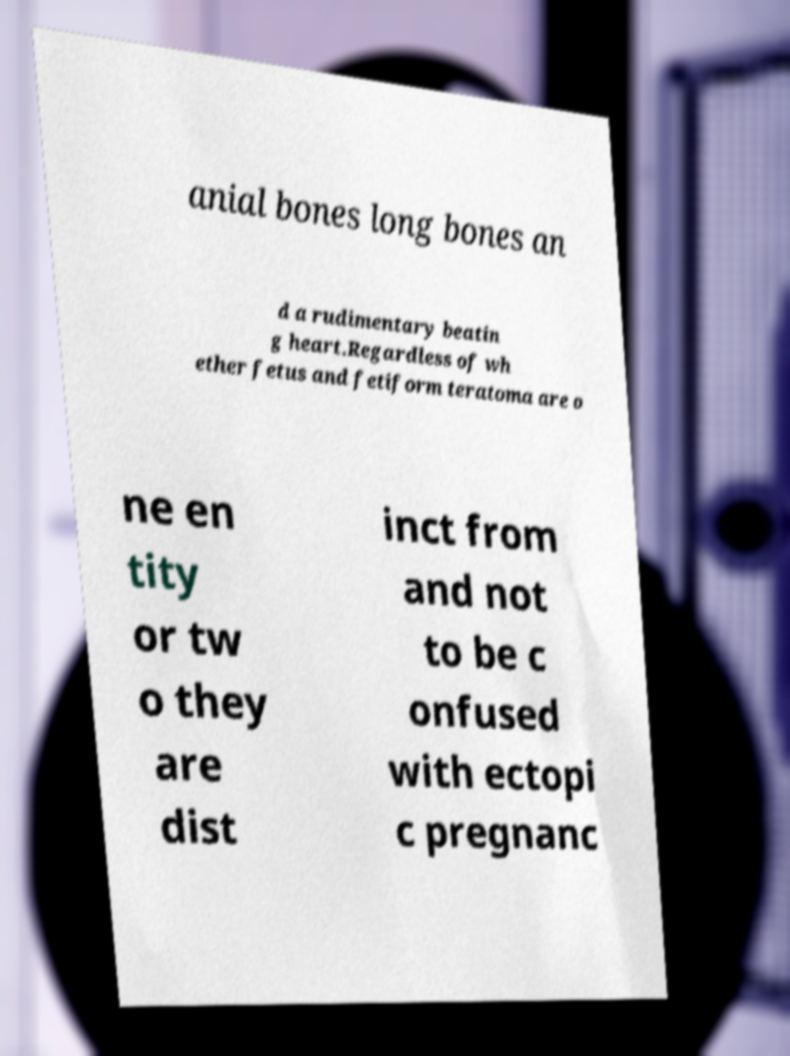What messages or text are displayed in this image? I need them in a readable, typed format. anial bones long bones an d a rudimentary beatin g heart.Regardless of wh ether fetus and fetiform teratoma are o ne en tity or tw o they are dist inct from and not to be c onfused with ectopi c pregnanc 